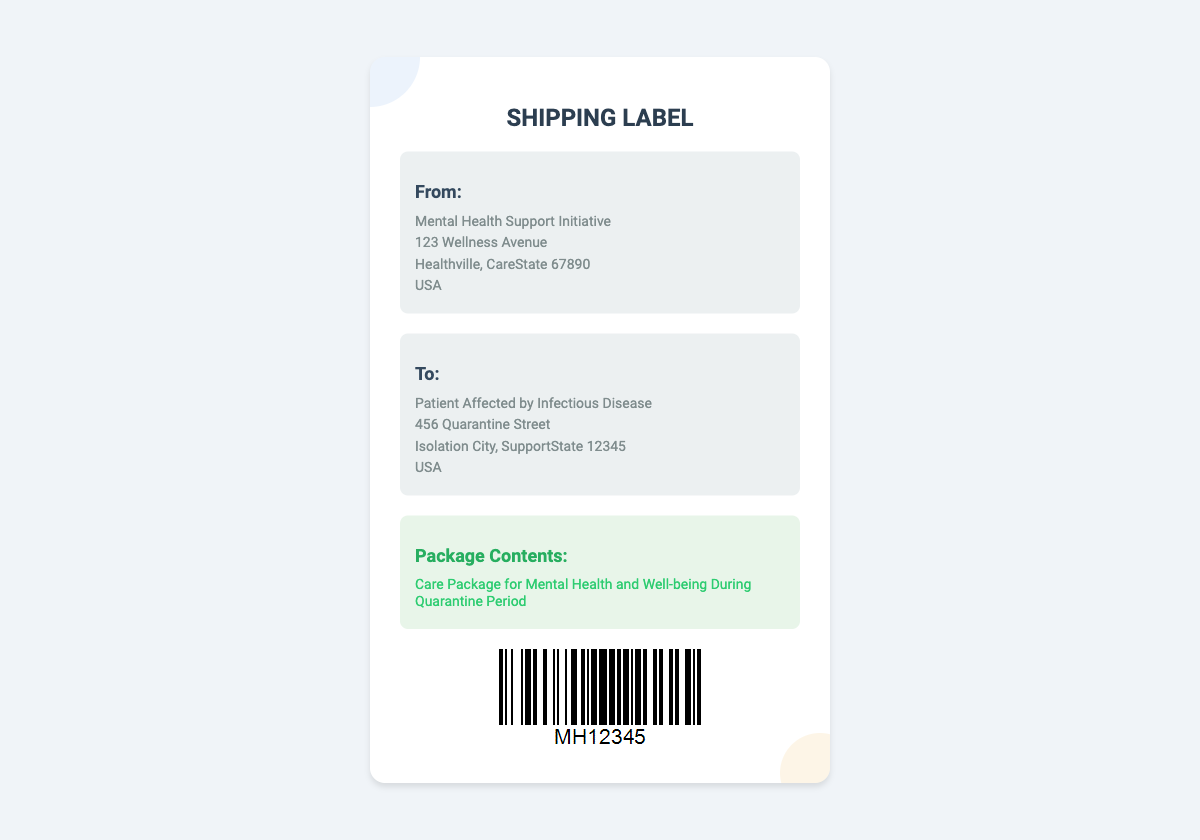What is the name of the sender? The sender is identified as the organization providing the care package, "Mental Health Support Initiative."
Answer: Mental Health Support Initiative What is the address of the sender? The address of the sender is listed in the document, including street, city, state, and postal code.
Answer: 123 Wellness Avenue, Healthville, CareState 67890, USA Who is the recipient of the package? The label specifies who is receiving the care package, which is a patient affected by an infectious disease.
Answer: Patient Affected by Infectious Disease What is the content of the package? The document mentions what the package contains, specifically aimed at mental health support.
Answer: Care Package for Mental Health and Well-being During Quarantine Period What is the postal code of the recipient? The unique identifier assigned to the recipient's location is found within the address section.
Answer: 12345 What type of document is this? This document is structured as a shipping label, which is used for identifying information for package delivery.
Answer: Shipping Label What is the significant color used for the sender's background? The design features a particular color that highlights the sender's details prominently in this document.
Answer: White What is the purpose of the care package? The document indicates the main objective of the care package, which aligns with supporting mental health during a specific period.
Answer: Mental health and well-being What is the barcode associated with? The barcode uniquely represents the shipment information and is specific to the care package sent.
Answer: MH12345 